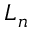<formula> <loc_0><loc_0><loc_500><loc_500>L _ { n }</formula> 